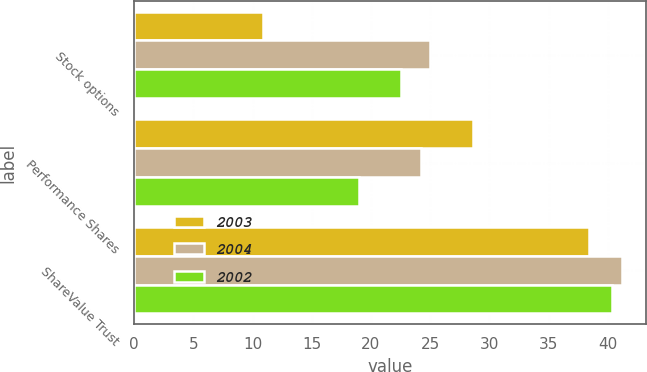Convert chart. <chart><loc_0><loc_0><loc_500><loc_500><stacked_bar_chart><ecel><fcel>Stock options<fcel>Performance Shares<fcel>ShareValue Trust<nl><fcel>2003<fcel>10.9<fcel>28.6<fcel>38.4<nl><fcel>2004<fcel>25<fcel>24.2<fcel>41.2<nl><fcel>2002<fcel>22.5<fcel>19<fcel>40.4<nl></chart> 